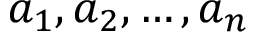Convert formula to latex. <formula><loc_0><loc_0><loc_500><loc_500>a _ { 1 } , a _ { 2 } , \dots , a _ { n }</formula> 